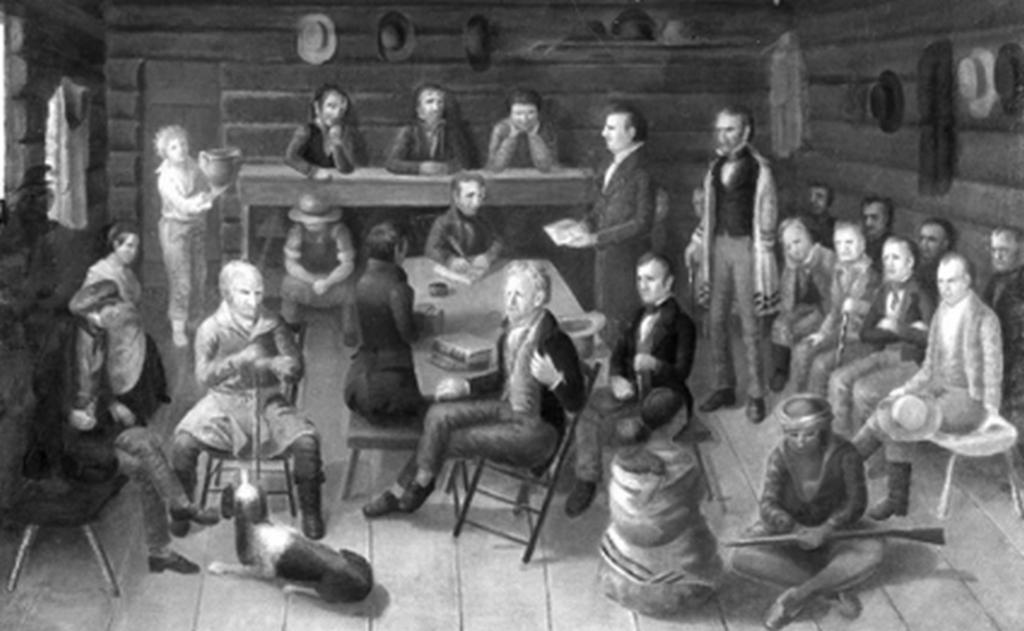Please provide a concise description of this image. There are three persons sitting on chairs and keeping their hands on the bench. In front of them, there are other persons , some of them are sitting on chairs, some are standing and a person who is holding a gun, sitting on the floor. There is a table. On which, there are some objects. In the background, there are caps arranged on the walls and there are windows. 